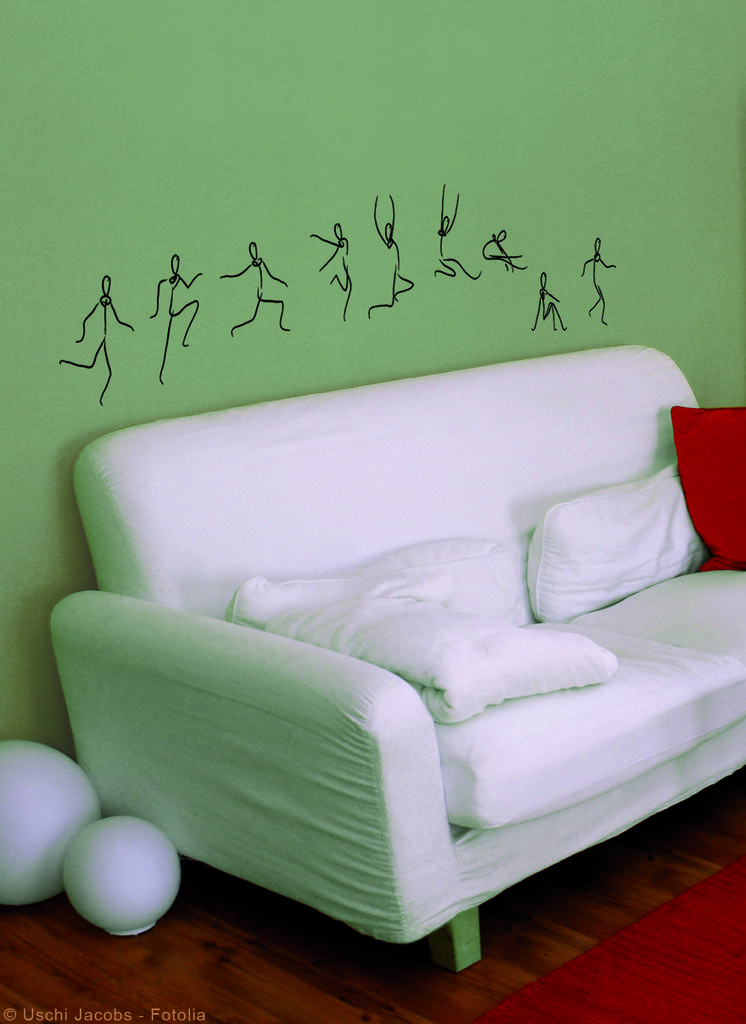What type of furniture is in the image? There is a white sofa in the image. What color is the wall behind the sofa? There is a green wall behind the sofa. What is hanging on the green wall? There is a black painting on the green wall. How many apples are on the white sofa in the image? There are no apples present on the white sofa in the image. 